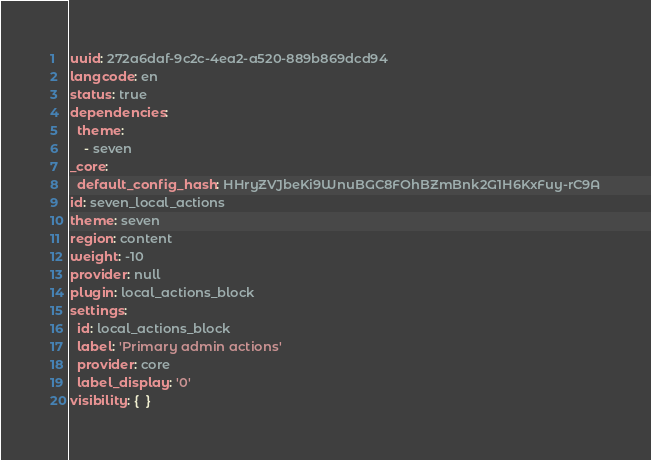<code> <loc_0><loc_0><loc_500><loc_500><_YAML_>uuid: 272a6daf-9c2c-4ea2-a520-889b869dcd94
langcode: en
status: true
dependencies:
  theme:
    - seven
_core:
  default_config_hash: HHryZVJbeKi9WnuBGC8FOhBZmBnk2G1H6KxFuy-rC9A
id: seven_local_actions
theme: seven
region: content
weight: -10
provider: null
plugin: local_actions_block
settings:
  id: local_actions_block
  label: 'Primary admin actions'
  provider: core
  label_display: '0'
visibility: {  }
</code> 